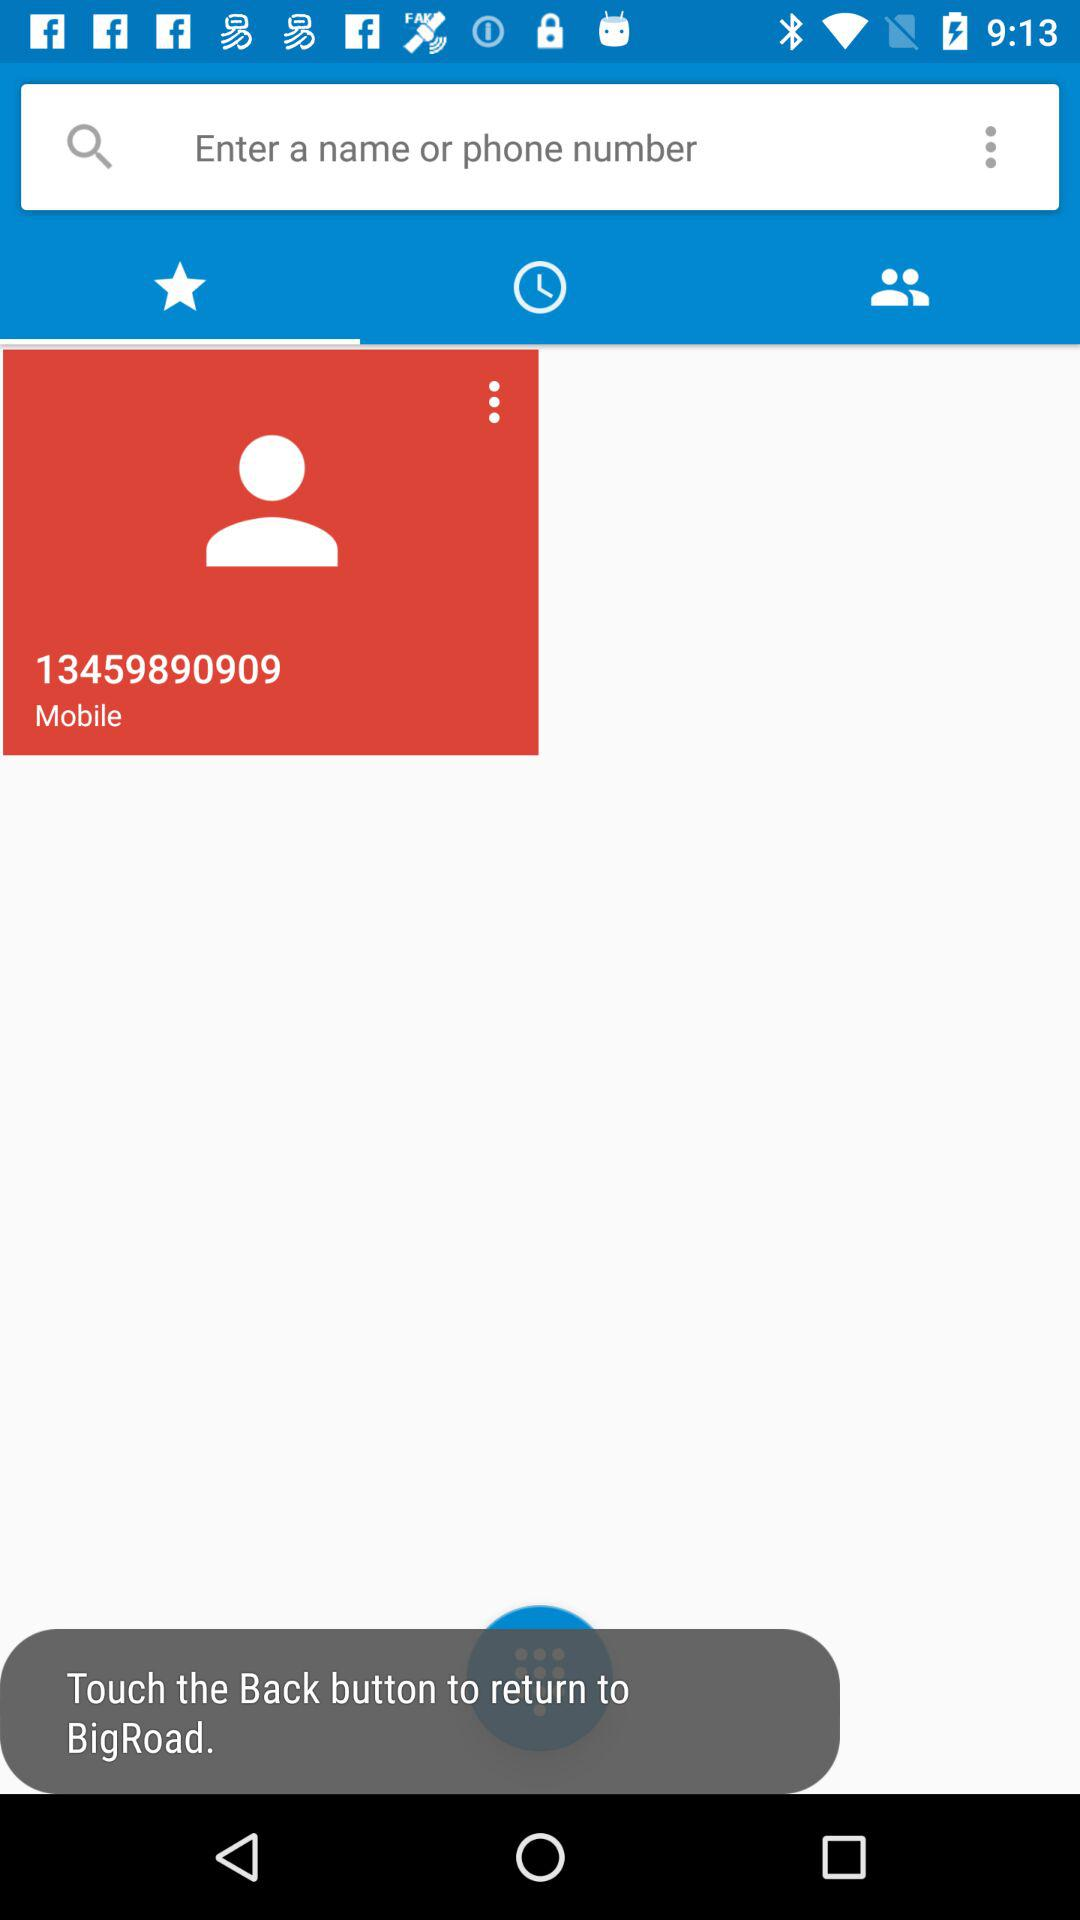What's the mobile number? The mobile number is 13459890909. 